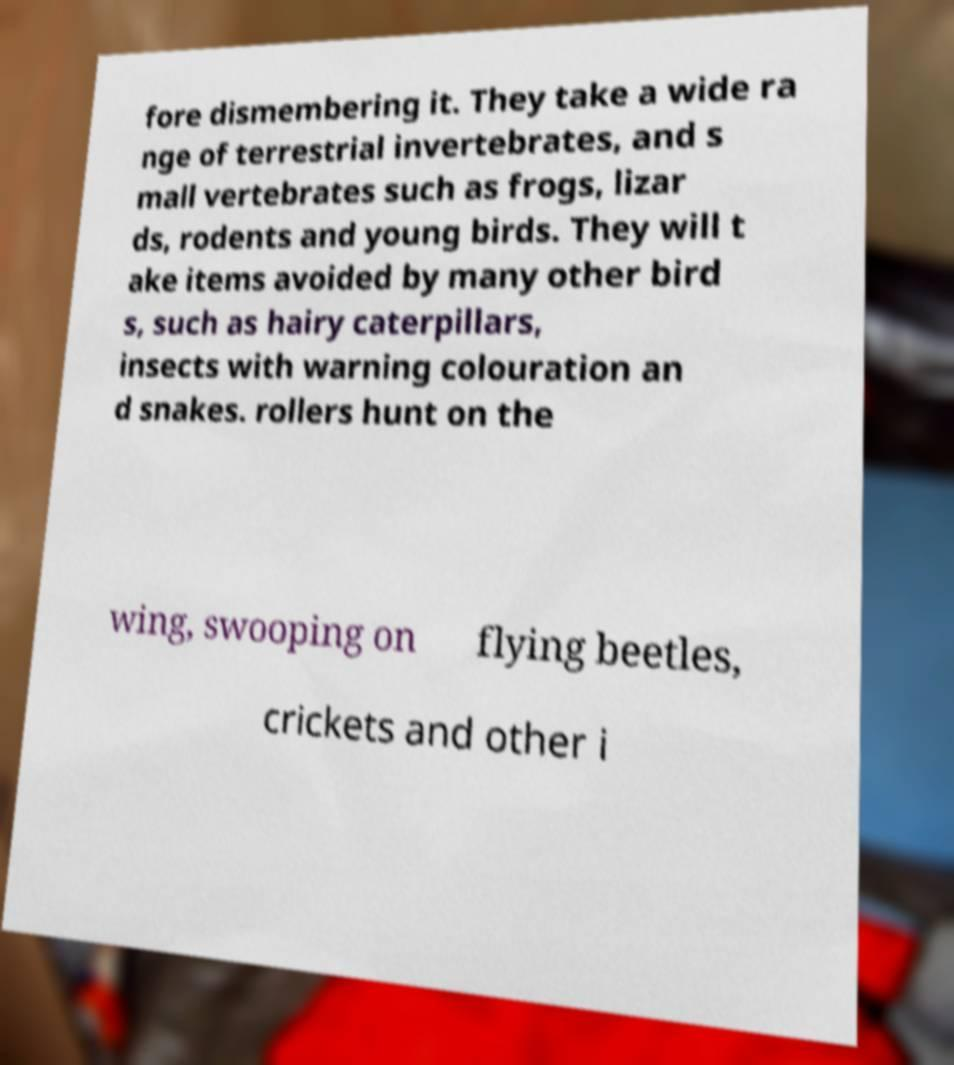There's text embedded in this image that I need extracted. Can you transcribe it verbatim? fore dismembering it. They take a wide ra nge of terrestrial invertebrates, and s mall vertebrates such as frogs, lizar ds, rodents and young birds. They will t ake items avoided by many other bird s, such as hairy caterpillars, insects with warning colouration an d snakes. rollers hunt on the wing, swooping on flying beetles, crickets and other i 